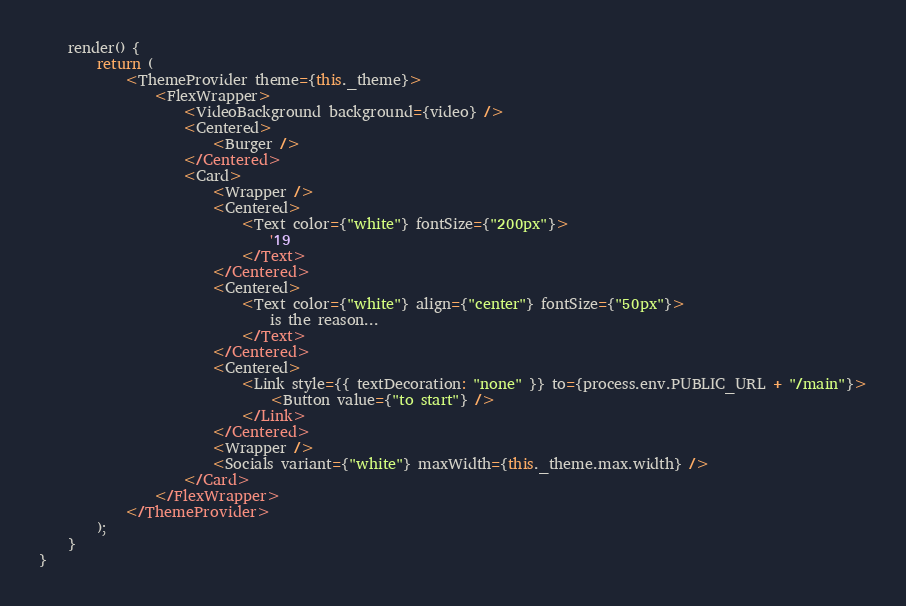<code> <loc_0><loc_0><loc_500><loc_500><_JavaScript_>    render() {
        return (
            <ThemeProvider theme={this._theme}>
                <FlexWrapper>
                    <VideoBackground background={video} />
                    <Centered>
                        <Burger />
                    </Centered>
                    <Card>
                        <Wrapper />
                        <Centered>
                            <Text color={"white"} fontSize={"200px"}>
                                '19
                            </Text>
                        </Centered>
                        <Centered>
                            <Text color={"white"} align={"center"} fontSize={"50px"}>
                                is the reason...
                            </Text>
                        </Centered>
                        <Centered>
                            <Link style={{ textDecoration: "none" }} to={process.env.PUBLIC_URL + "/main"}>
                                <Button value={"to start"} />
                            </Link>
                        </Centered>
                        <Wrapper />
                        <Socials variant={"white"} maxWidth={this._theme.max.width} />
                    </Card>
                </FlexWrapper>
            </ThemeProvider>
        );
    }
}
</code> 